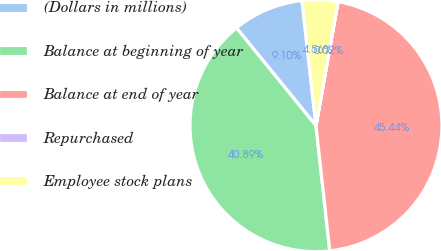Convert chart to OTSL. <chart><loc_0><loc_0><loc_500><loc_500><pie_chart><fcel>(Dollars in millions)<fcel>Balance at beginning of year<fcel>Balance at end of year<fcel>Repurchased<fcel>Employee stock plans<nl><fcel>9.1%<fcel>40.89%<fcel>45.44%<fcel>0.02%<fcel>4.56%<nl></chart> 